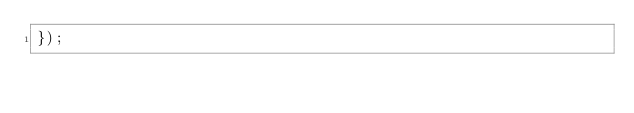<code> <loc_0><loc_0><loc_500><loc_500><_JavaScript_>});
</code> 